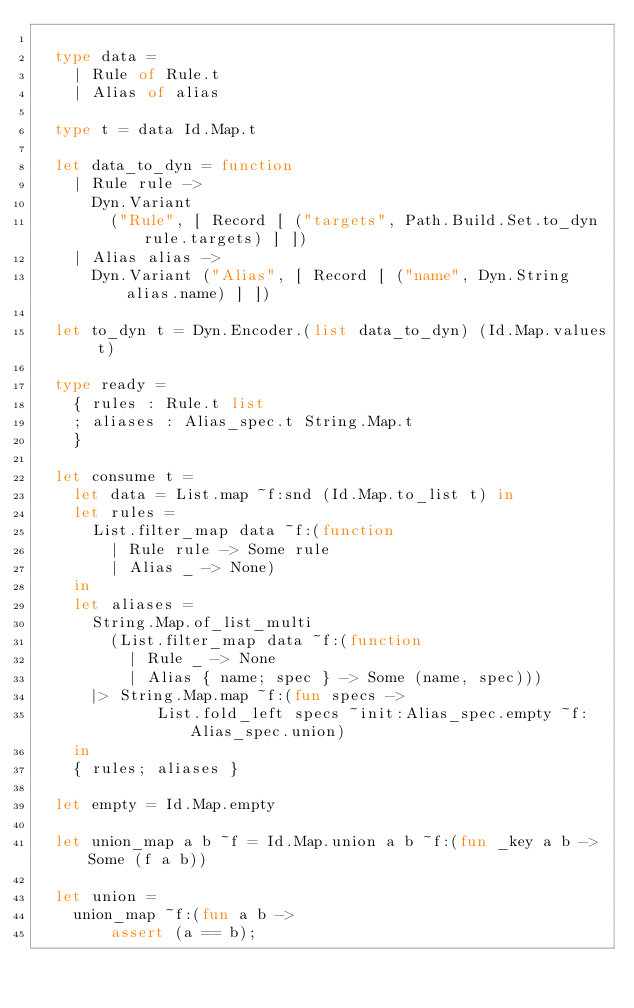<code> <loc_0><loc_0><loc_500><loc_500><_OCaml_>
  type data =
    | Rule of Rule.t
    | Alias of alias

  type t = data Id.Map.t

  let data_to_dyn = function
    | Rule rule ->
      Dyn.Variant
        ("Rule", [ Record [ ("targets", Path.Build.Set.to_dyn rule.targets) ] ])
    | Alias alias ->
      Dyn.Variant ("Alias", [ Record [ ("name", Dyn.String alias.name) ] ])

  let to_dyn t = Dyn.Encoder.(list data_to_dyn) (Id.Map.values t)

  type ready =
    { rules : Rule.t list
    ; aliases : Alias_spec.t String.Map.t
    }

  let consume t =
    let data = List.map ~f:snd (Id.Map.to_list t) in
    let rules =
      List.filter_map data ~f:(function
        | Rule rule -> Some rule
        | Alias _ -> None)
    in
    let aliases =
      String.Map.of_list_multi
        (List.filter_map data ~f:(function
          | Rule _ -> None
          | Alias { name; spec } -> Some (name, spec)))
      |> String.Map.map ~f:(fun specs ->
             List.fold_left specs ~init:Alias_spec.empty ~f:Alias_spec.union)
    in
    { rules; aliases }

  let empty = Id.Map.empty

  let union_map a b ~f = Id.Map.union a b ~f:(fun _key a b -> Some (f a b))

  let union =
    union_map ~f:(fun a b ->
        assert (a == b);</code> 